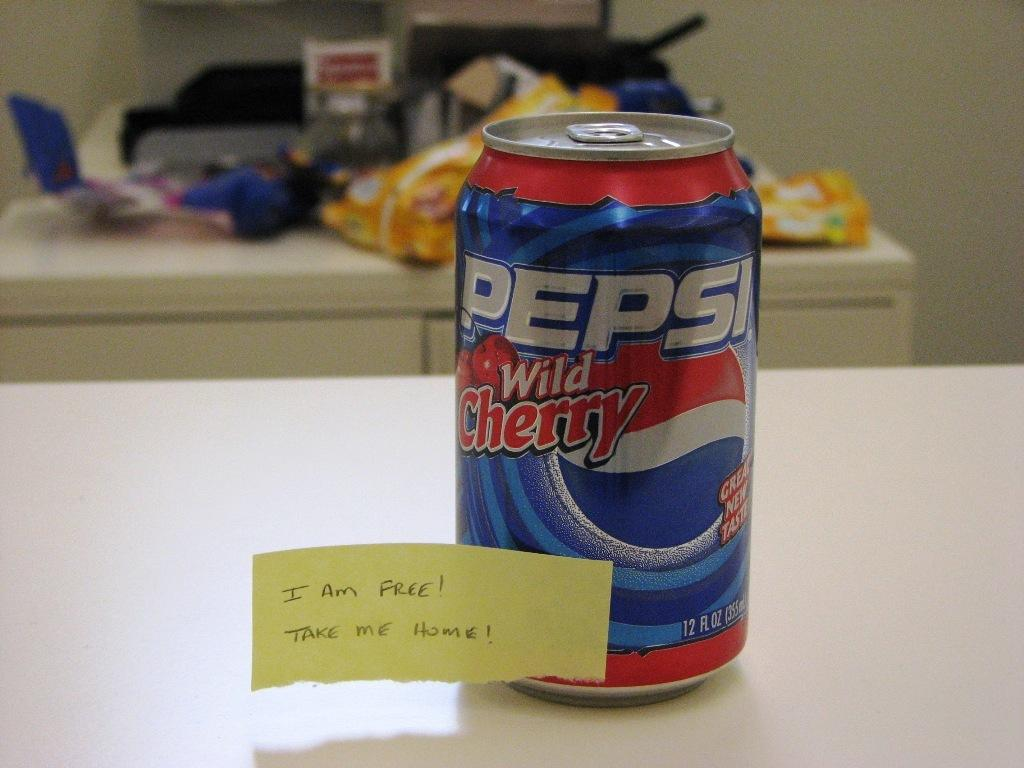<image>
Summarize the visual content of the image. a pepsi can that has a note on it 